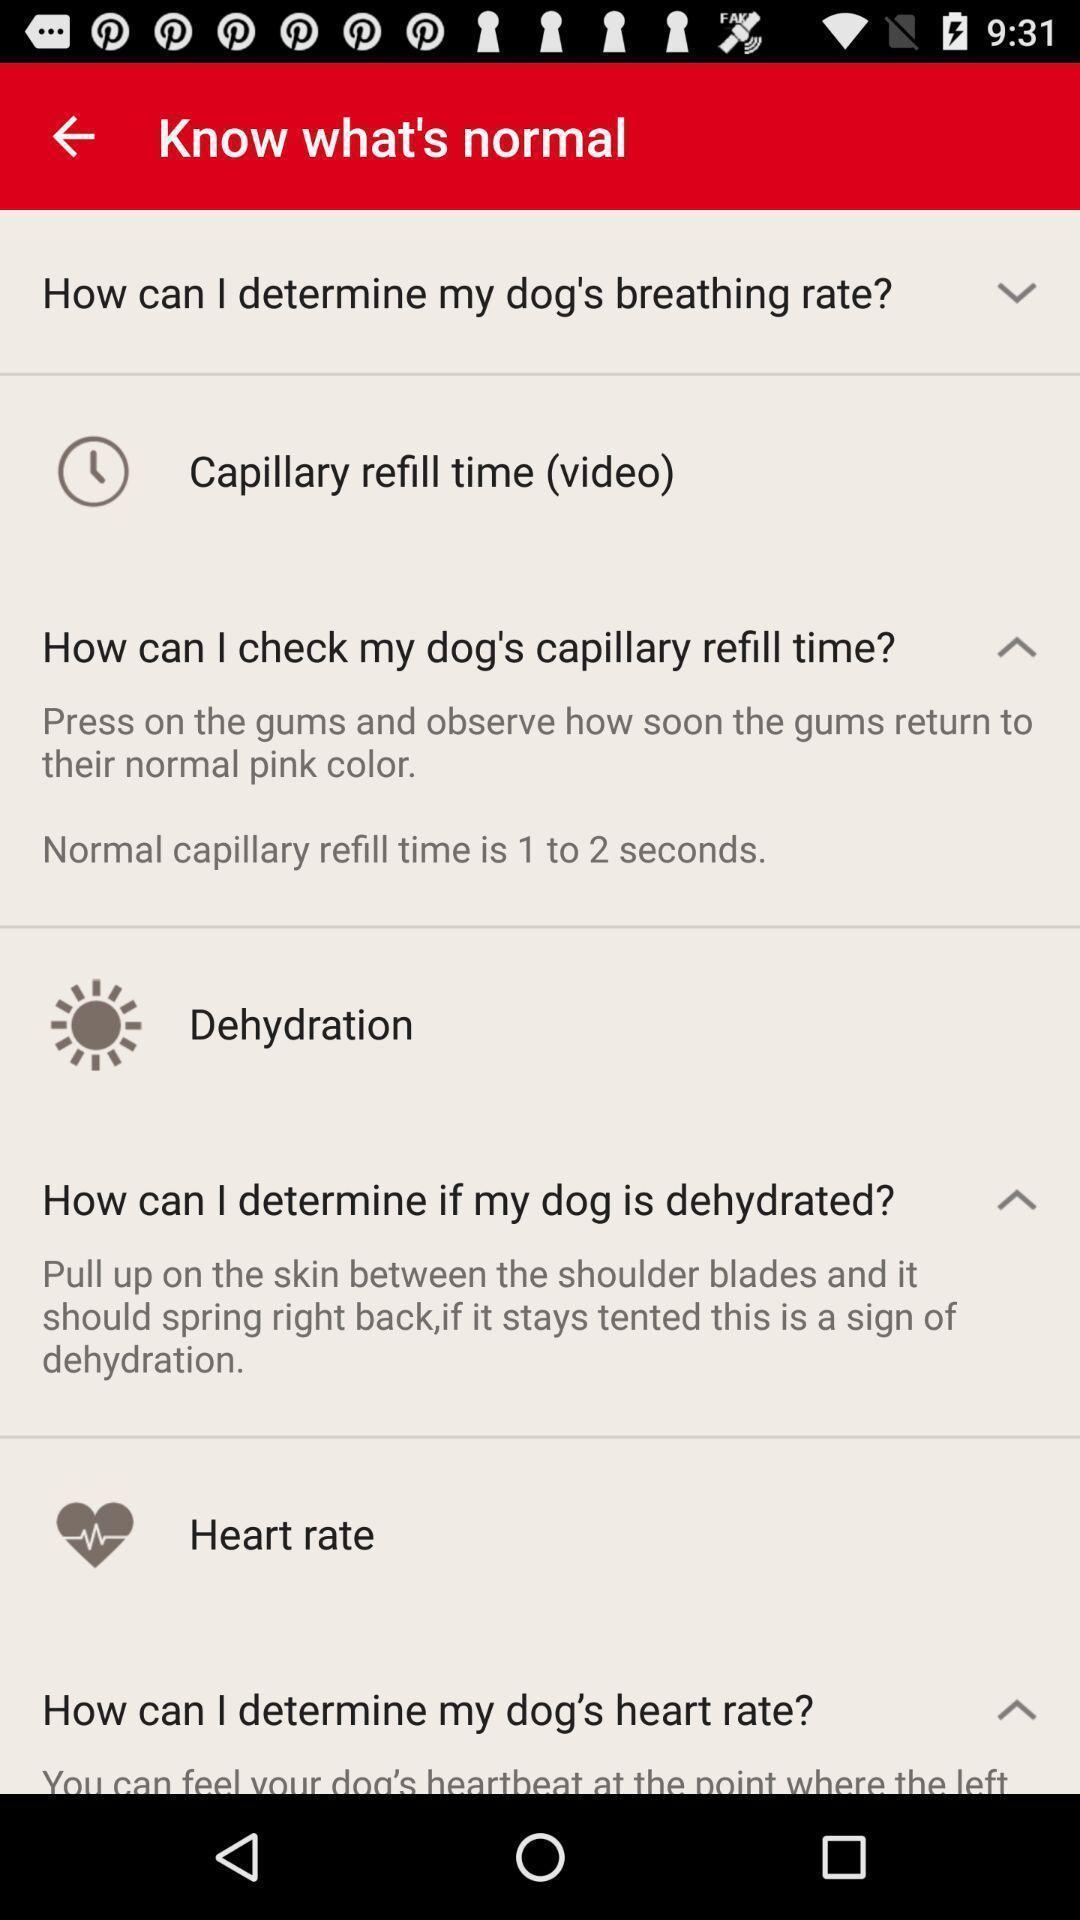What details can you identify in this image? Page showing information from a medical app. 